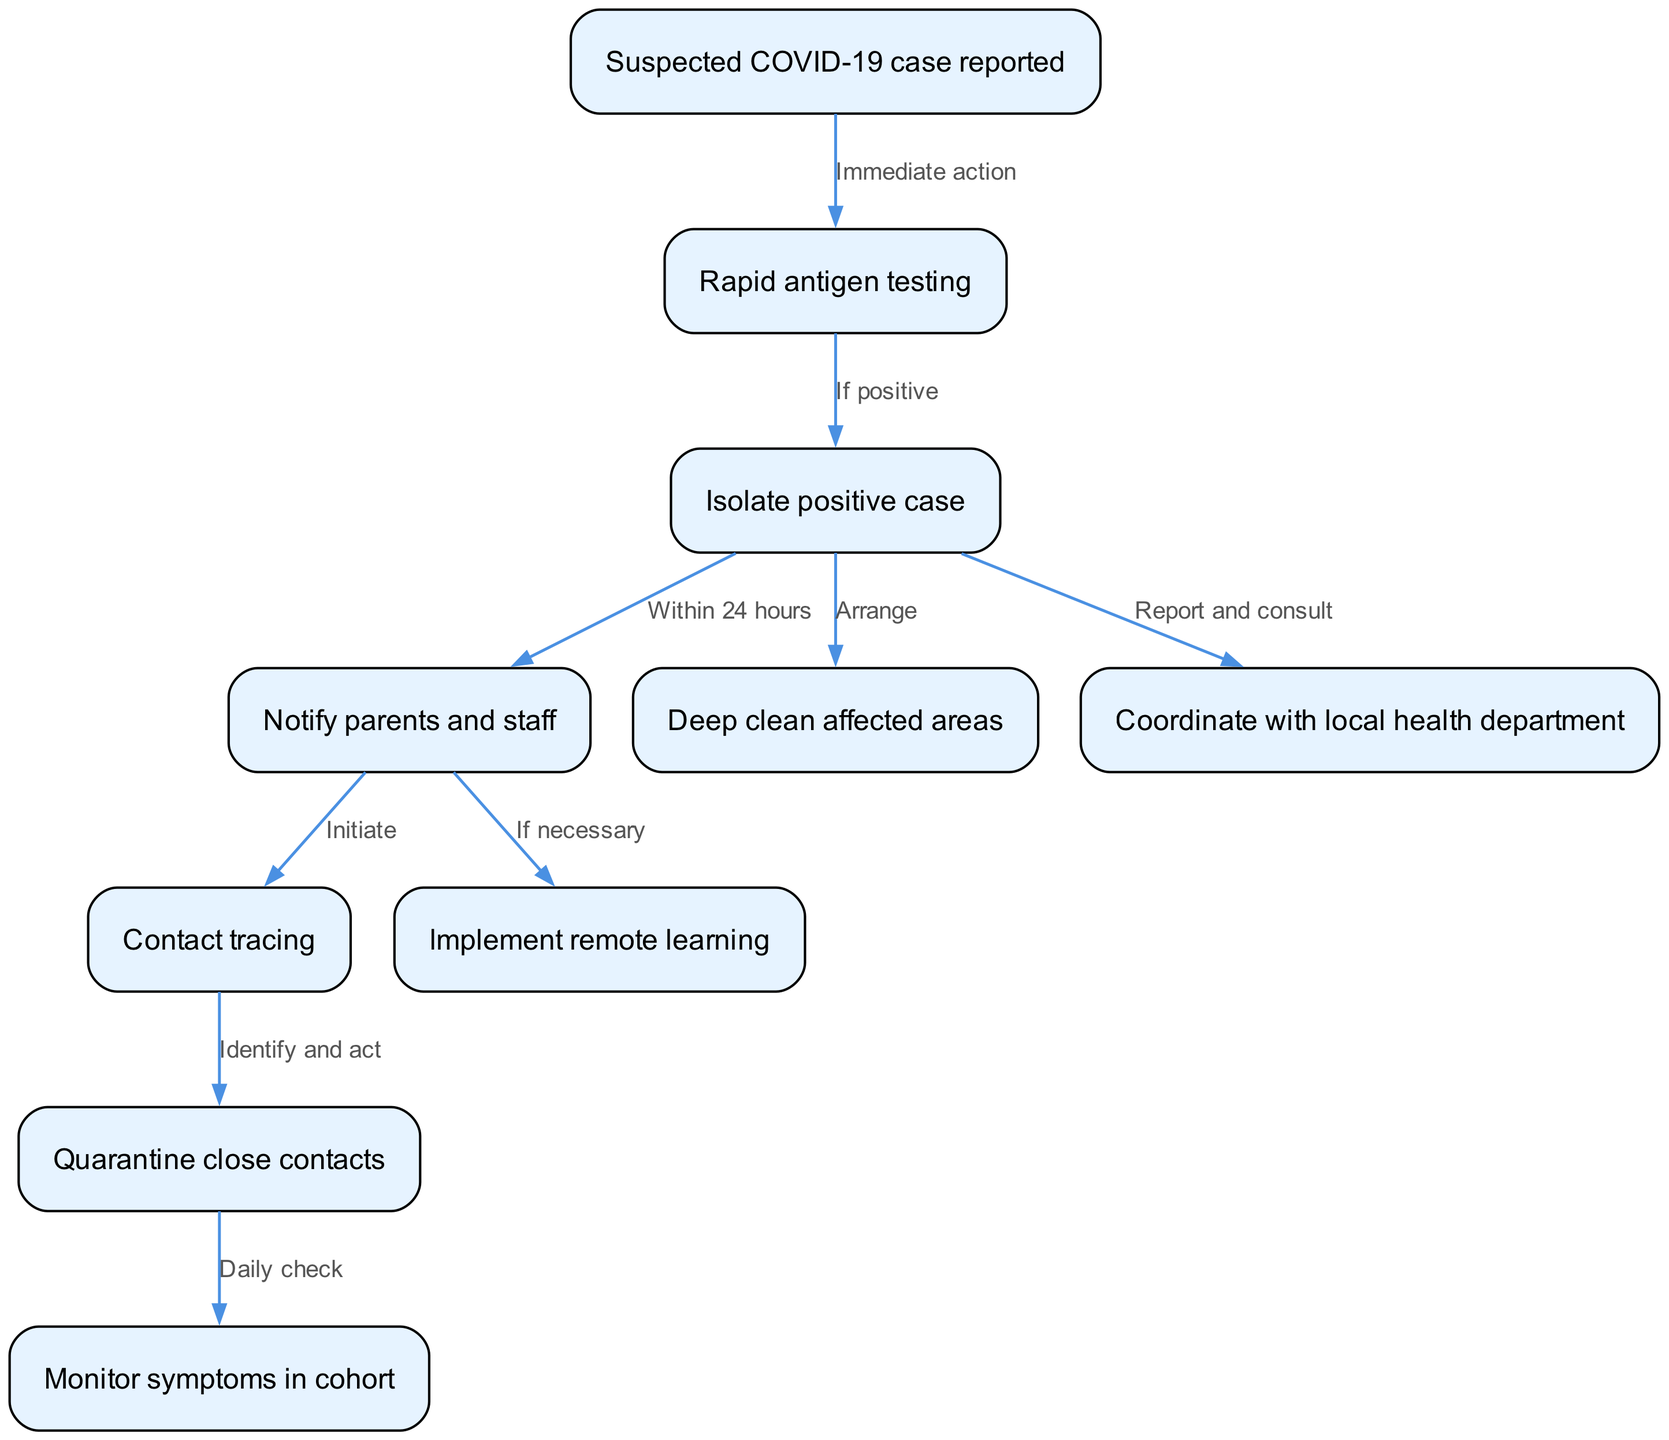What is the first node in the diagram? The first node reported in the diagram is "Suspected COVID-19 case reported". It is the starting point of the clinical pathway and represents the initiation of the process when a suspected case comes to attention.
Answer: Suspected COVID-19 case reported How many total nodes are in the diagram? The diagram contains 10 nodes in total, which represent various steps in managing COVID-19 outbreaks in preschools.
Answer: 10 What action occurs if the rapid antigen test is positive? If the rapid antigen test result is positive, the next action is to "Isolate positive case," indicating the importance of immediate isolation in response to a confirmed positive test.
Answer: Isolate positive case What happens after isolating the positive case? After isolating the positive case, the next step is to "Notify parents and staff," which roles towards communication and transparency within the preschool community.
Answer: Notify parents and staff What is initiated after notifying parents and staff? After notifying parents and staff, the process moves to "Contact tracing," which is essential for identifying individuals who may have been exposed to the virus.
Answer: Contact tracing What is the relationship between "Isolate positive case" and "Deep clean affected areas"? The "Deep clean affected areas" step occurs after "Isolate positive case," indicating that these steps are connected by the need to ensure a safe environment once a positive case is confirmed.
Answer: Arrange How are close contacts managed following contact tracing? Following contact tracing, close contacts are managed by "Quarantine close contacts," demonstrating the action taken to prevent further transmission of COVID-19.
Answer: Quarantine close contacts What is monitored daily in the cohort? The diagram indicates that "Monitor symptoms in cohort" is the action taken daily in the cohort, reflecting the need for ongoing surveillance for symptoms among the group.
Answer: Monitor symptoms in cohort What is implemented if necessary after notifying parents and staff? If necessary, the action taken after notifying parents and staff is to "Implement remote learning," which provides an alternative education method during an outbreak.
Answer: Implement remote learning 